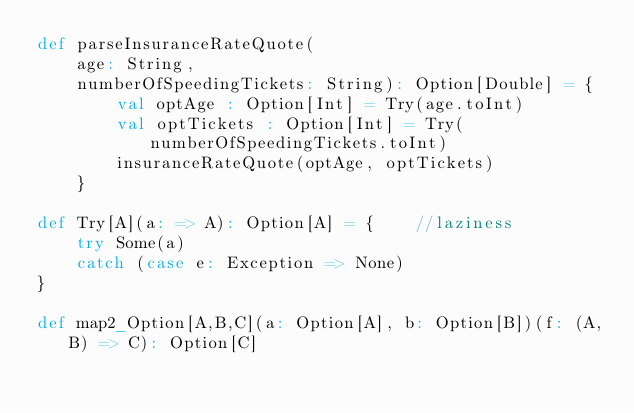<code> <loc_0><loc_0><loc_500><loc_500><_Scala_>def parseInsuranceRateQuote(
    age: String,
    numberOfSpeedingTickets: String): Option[Double] = {
        val optAge : Option[Int] = Try(age.toInt)
        val optTickets : Option[Int] = Try(numberOfSpeedingTickets.toInt)
        insuranceRateQuote(optAge, optTickets)
    }

def Try[A](a: => A): Option[A] = {    //laziness
    try Some(a)
    catch (case e: Exception => None)
}

def map2_Option[A,B,C](a: Option[A], b: Option[B])(f: (A,B) => C): Option[C]</code> 